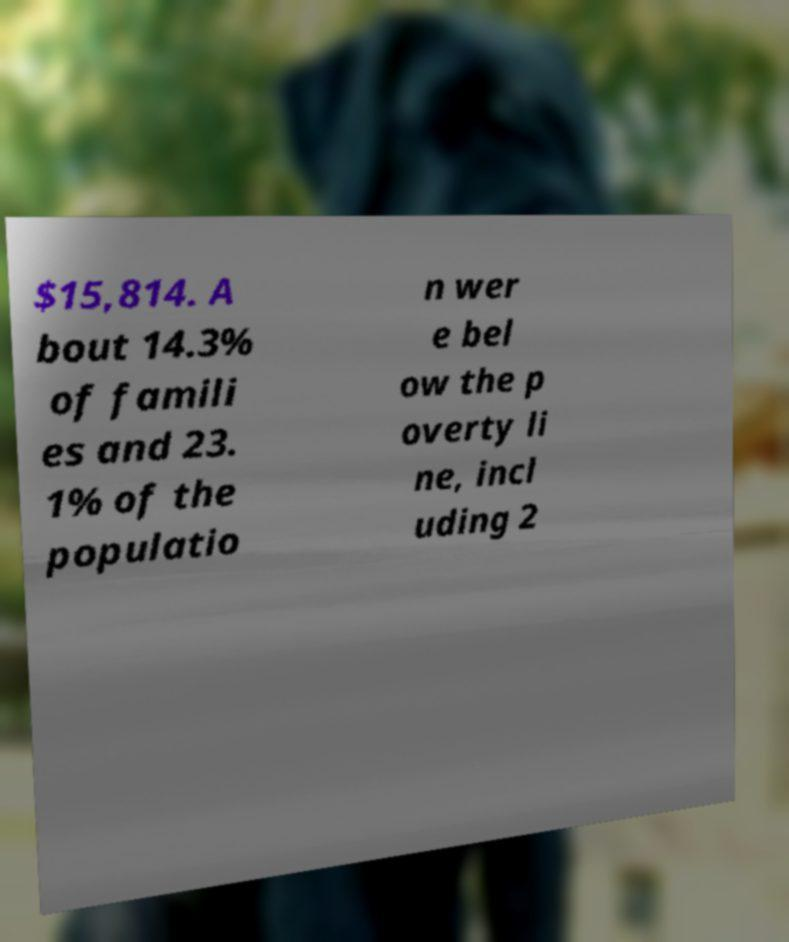I need the written content from this picture converted into text. Can you do that? $15,814. A bout 14.3% of famili es and 23. 1% of the populatio n wer e bel ow the p overty li ne, incl uding 2 